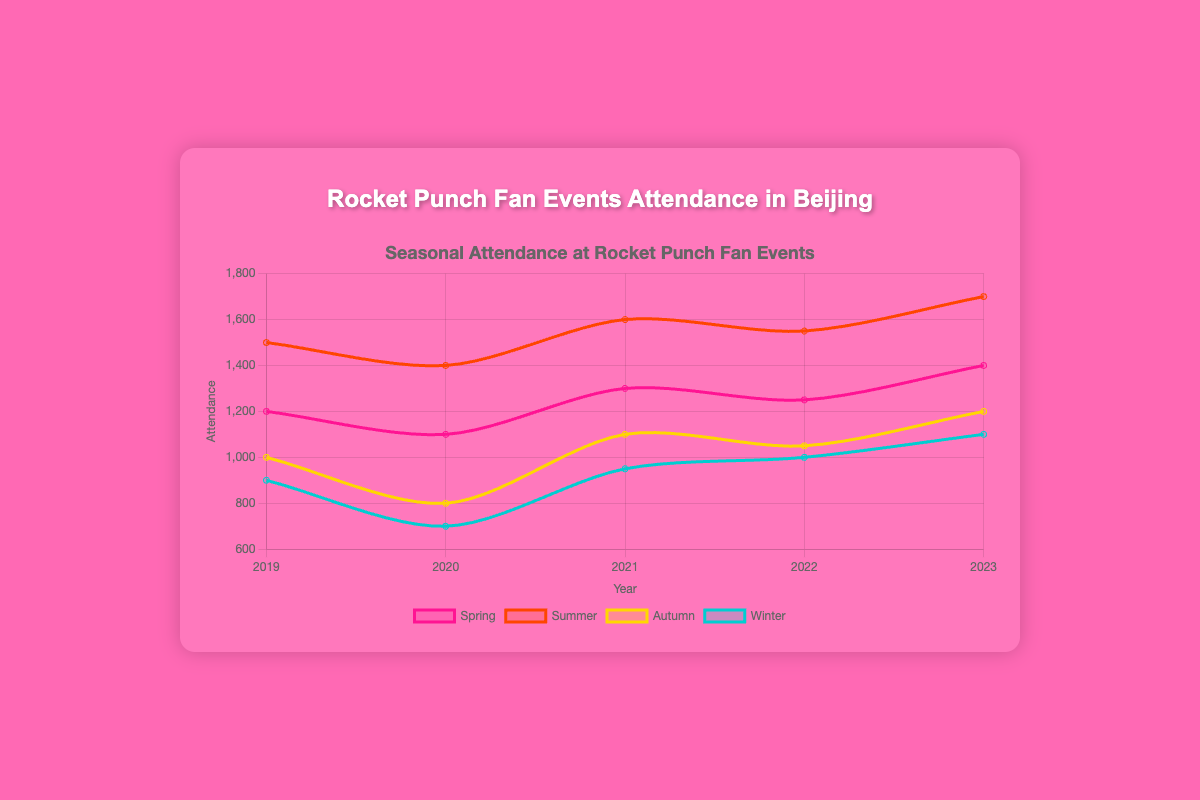What is the total attendance for all seasons in 2023? To determine the total attendance for all seasons in 2023, sum the attendance numbers for spring, summer, autumn, and winter: 1400 (spring) + 1700 (summer) + 1200 (autumn) + 1100 (winter).
Answer: 5400 Which season had the highest attendance overall from 2019 to 2023? To find the highest season, compare the maximum attendance values for each season across all years: Spring peaks at 1400 in 2023, Summer peaks at 1700 in 2023, Autumn peaks at 1200 in 2023, Winter peaks at 1100 in 2023. The highest value is in Summer 2023.
Answer: Summer 2023 Did the spring attendance in 2022 see an increase or decrease compared to 2021? Compare the spring attendance values for 2022 and 2021: 2022 was 1250 and 2021 was 1300. Since 1250 < 1300, it decreased.
Answer: Decrease By how much did winter attendance increase from 2020 to 2023? Subtract the winter attendance in 2020 from that in 2023: 1100 (2023) - 700 (2020).
Answer: 400 What is the average attendance for autumn season from 2019 to 2023? Add up the autumn attendance for each year: 1000 (2019) + 800 (2020) + 1100 (2021) + 1050 (2022) + 1200 (2023) = 5150, then divide by the number of years: 5150 / 5.
Answer: 1030 Which year had the lowest total annual attendance for all seasons? Calculate the total annual attendance for each year: 2019 total = 1200 + 1500 + 1000 + 900 = 4600, 2020 total = 1100 + 1400 + 800 + 700 = 4000, 2021 total = 1300 + 1600 + 1100 + 950 = 4950, 2022 total = 1250 + 1550 + 1050 + 1000 = 4850, 2023 total = 1400 + 1700 + 1200 + 1100 = 5400. The lowest total is in 2020.
Answer: 2020 How does the 2021 summer attendance compare to the 2019 summer attendance? Compare the summer attendance for 2021 and 2019: 2021 was 1600 and 2019 was 1500. Since 1600 > 1500, the 2021 attendance is higher.
Answer: Higher What is the combined attendance change from summer to autumn in 2021? Subtract the autumn attendance from the summer attendance for 2021: 1600 (summer) - 1100 (autumn).
Answer: 500 Of all the years shown, in which season did the attendance drop in 2020 as compared to 2019? Compare 2020 and 2019 for each season: Spring 1200 (2019) to 1100 (2020), Summer 1500 (2019) to 1400 (2020), Autumn 1000 (2019) to 800 (2020), Winter 900 (2019) to 700 (2020). Attendance dropped in all seasons.
Answer: All seasons 